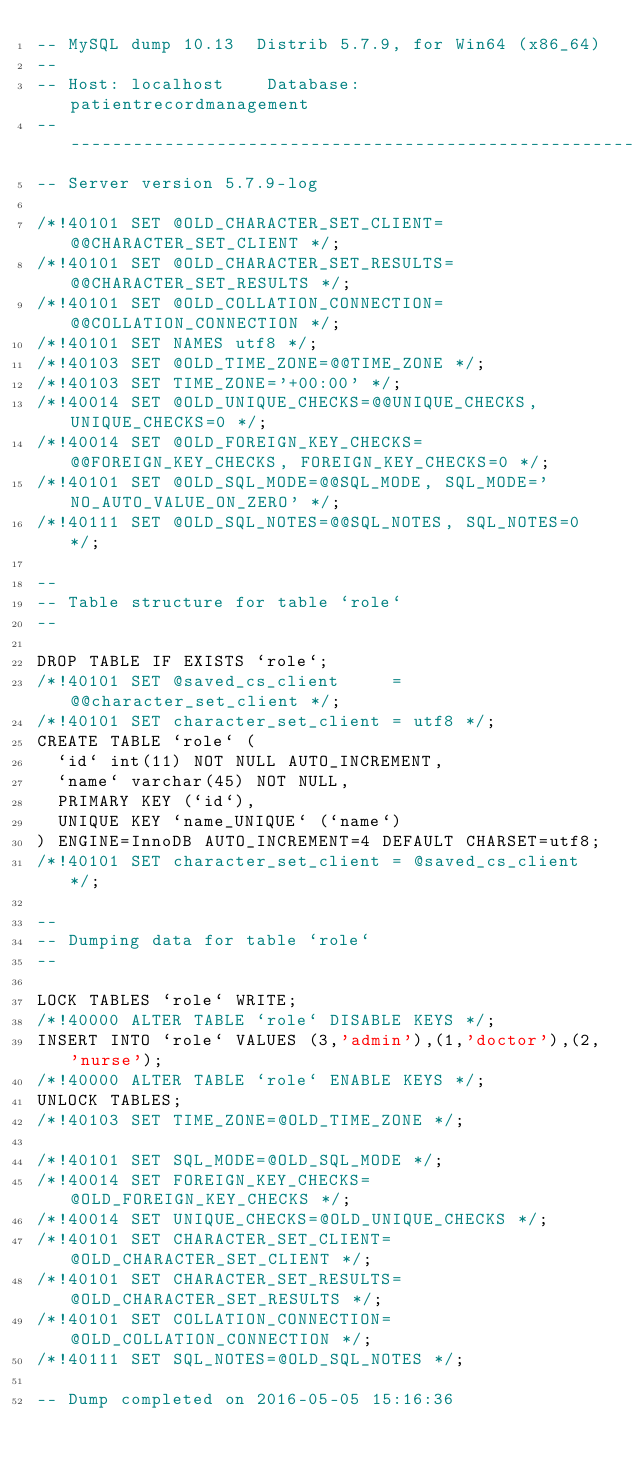Convert code to text. <code><loc_0><loc_0><loc_500><loc_500><_SQL_>-- MySQL dump 10.13  Distrib 5.7.9, for Win64 (x86_64)
--
-- Host: localhost    Database: patientrecordmanagement
-- ------------------------------------------------------
-- Server version	5.7.9-log

/*!40101 SET @OLD_CHARACTER_SET_CLIENT=@@CHARACTER_SET_CLIENT */;
/*!40101 SET @OLD_CHARACTER_SET_RESULTS=@@CHARACTER_SET_RESULTS */;
/*!40101 SET @OLD_COLLATION_CONNECTION=@@COLLATION_CONNECTION */;
/*!40101 SET NAMES utf8 */;
/*!40103 SET @OLD_TIME_ZONE=@@TIME_ZONE */;
/*!40103 SET TIME_ZONE='+00:00' */;
/*!40014 SET @OLD_UNIQUE_CHECKS=@@UNIQUE_CHECKS, UNIQUE_CHECKS=0 */;
/*!40014 SET @OLD_FOREIGN_KEY_CHECKS=@@FOREIGN_KEY_CHECKS, FOREIGN_KEY_CHECKS=0 */;
/*!40101 SET @OLD_SQL_MODE=@@SQL_MODE, SQL_MODE='NO_AUTO_VALUE_ON_ZERO' */;
/*!40111 SET @OLD_SQL_NOTES=@@SQL_NOTES, SQL_NOTES=0 */;

--
-- Table structure for table `role`
--

DROP TABLE IF EXISTS `role`;
/*!40101 SET @saved_cs_client     = @@character_set_client */;
/*!40101 SET character_set_client = utf8 */;
CREATE TABLE `role` (
  `id` int(11) NOT NULL AUTO_INCREMENT,
  `name` varchar(45) NOT NULL,
  PRIMARY KEY (`id`),
  UNIQUE KEY `name_UNIQUE` (`name`)
) ENGINE=InnoDB AUTO_INCREMENT=4 DEFAULT CHARSET=utf8;
/*!40101 SET character_set_client = @saved_cs_client */;

--
-- Dumping data for table `role`
--

LOCK TABLES `role` WRITE;
/*!40000 ALTER TABLE `role` DISABLE KEYS */;
INSERT INTO `role` VALUES (3,'admin'),(1,'doctor'),(2,'nurse');
/*!40000 ALTER TABLE `role` ENABLE KEYS */;
UNLOCK TABLES;
/*!40103 SET TIME_ZONE=@OLD_TIME_ZONE */;

/*!40101 SET SQL_MODE=@OLD_SQL_MODE */;
/*!40014 SET FOREIGN_KEY_CHECKS=@OLD_FOREIGN_KEY_CHECKS */;
/*!40014 SET UNIQUE_CHECKS=@OLD_UNIQUE_CHECKS */;
/*!40101 SET CHARACTER_SET_CLIENT=@OLD_CHARACTER_SET_CLIENT */;
/*!40101 SET CHARACTER_SET_RESULTS=@OLD_CHARACTER_SET_RESULTS */;
/*!40101 SET COLLATION_CONNECTION=@OLD_COLLATION_CONNECTION */;
/*!40111 SET SQL_NOTES=@OLD_SQL_NOTES */;

-- Dump completed on 2016-05-05 15:16:36
</code> 